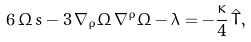<formula> <loc_0><loc_0><loc_500><loc_500>6 \, \Omega \, s - 3 \, \nabla _ { \rho } \Omega \, \nabla ^ { \rho } \Omega - \lambda = - \frac { \kappa } { 4 } \, \hat { T } ,</formula> 